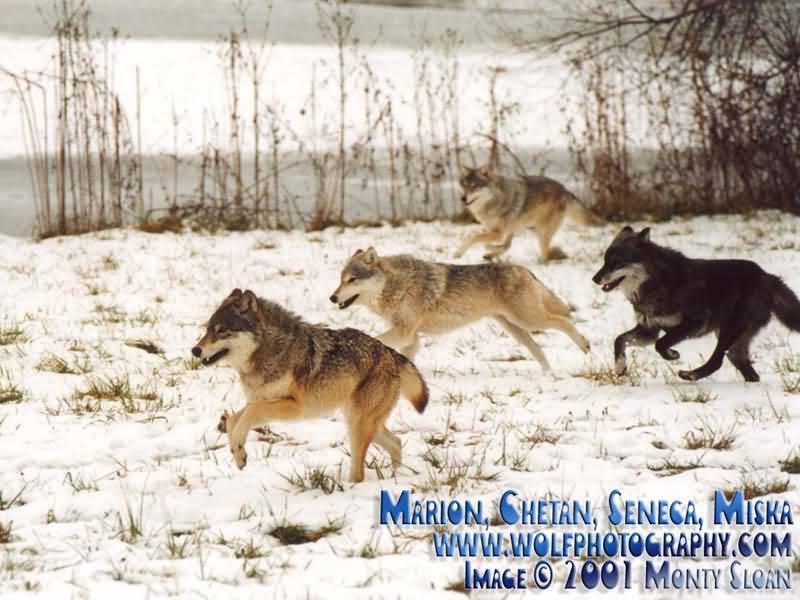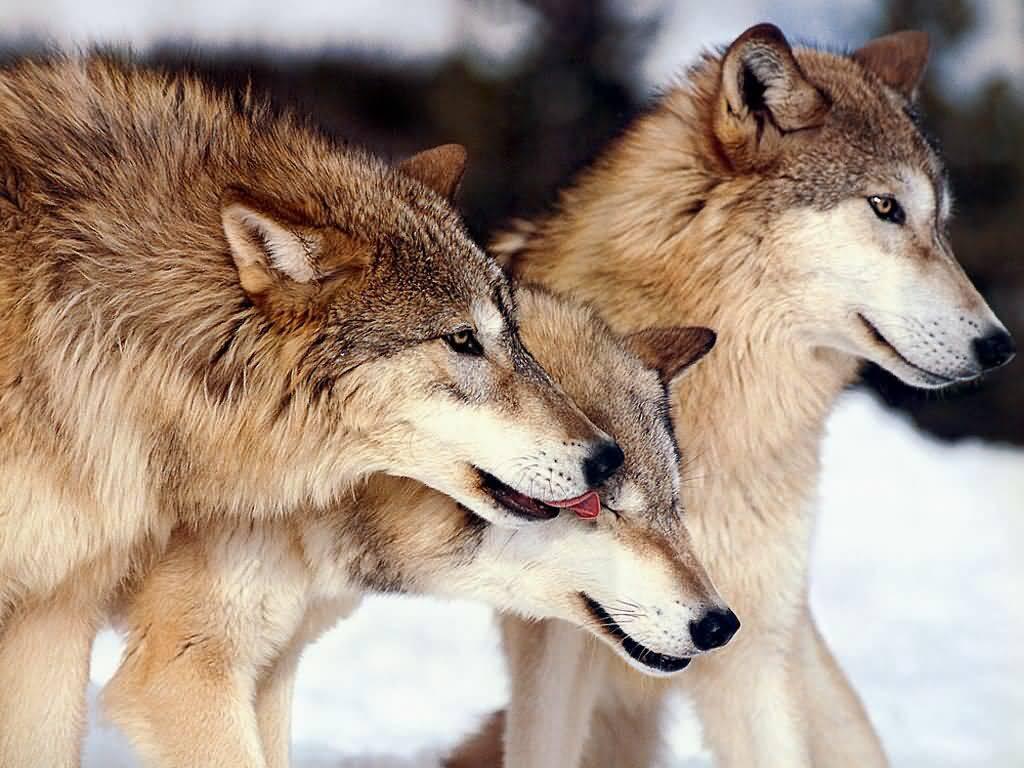The first image is the image on the left, the second image is the image on the right. Considering the images on both sides, is "The left image contains no more than two wolves." valid? Answer yes or no. No. The first image is the image on the left, the second image is the image on the right. Evaluate the accuracy of this statement regarding the images: "An image contains exactly two wolves, which are close together in a snowy scene.". Is it true? Answer yes or no. No. 